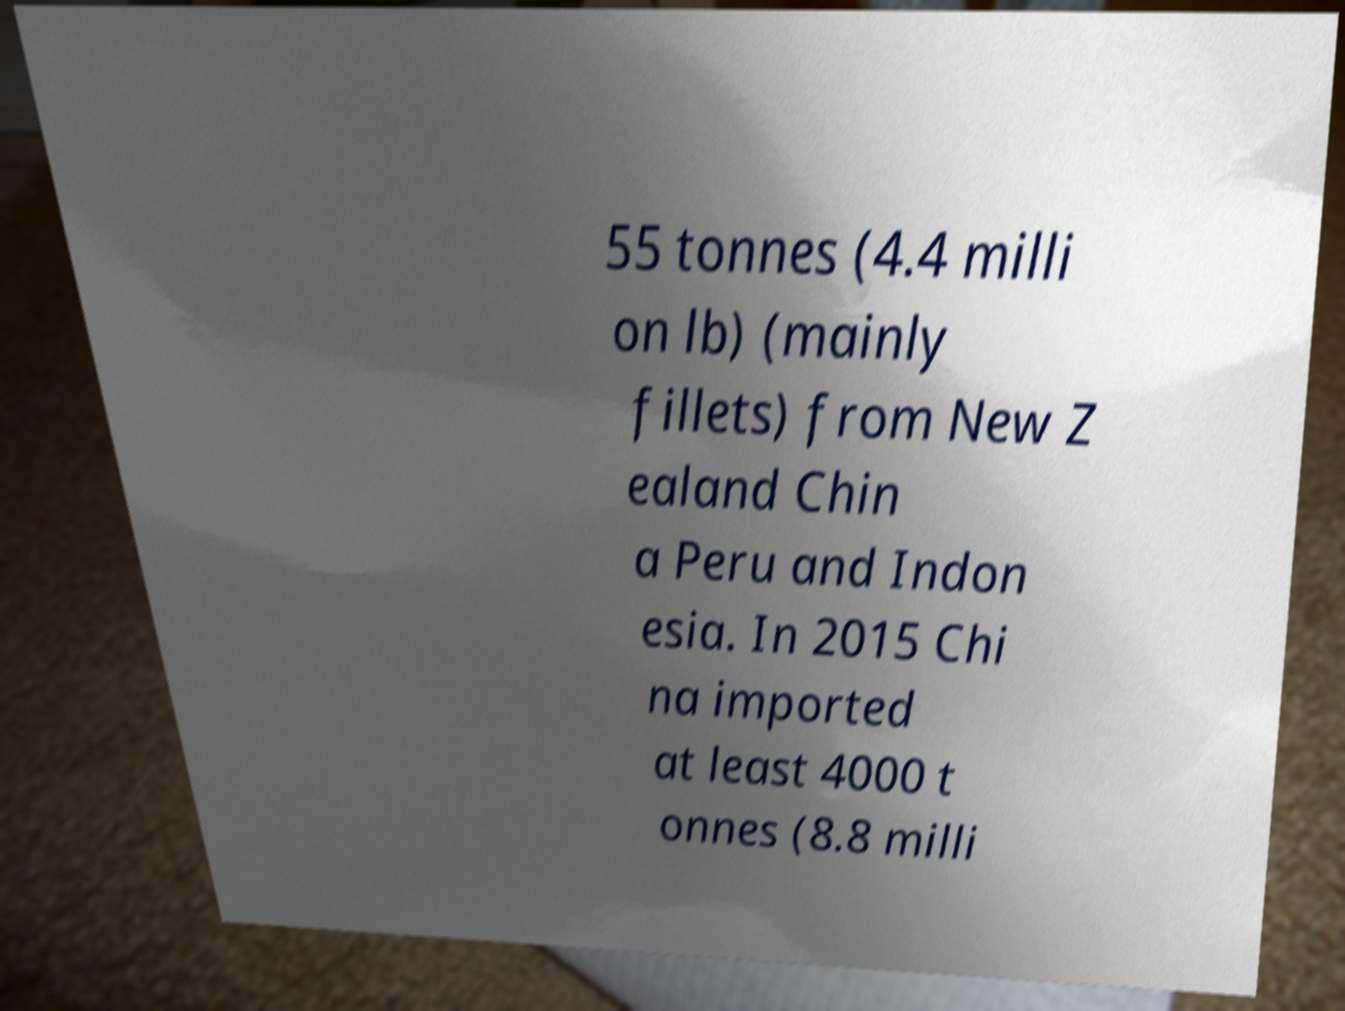Can you accurately transcribe the text from the provided image for me? 55 tonnes (4.4 milli on lb) (mainly fillets) from New Z ealand Chin a Peru and Indon esia. In 2015 Chi na imported at least 4000 t onnes (8.8 milli 